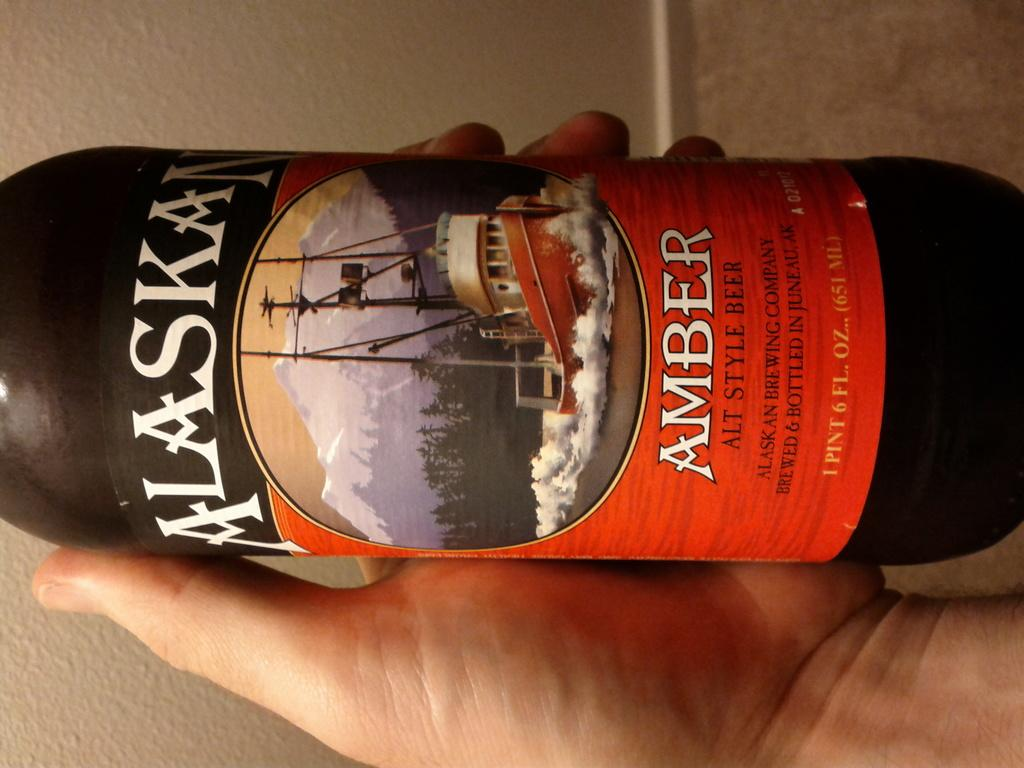Provide a one-sentence caption for the provided image. man holding a beer bottle called amber alaska. 